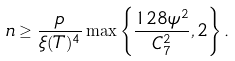<formula> <loc_0><loc_0><loc_500><loc_500>n \geq \frac { p } { \xi ( T ) ^ { 4 } } \max \left \{ \frac { 1 2 8 \psi ^ { 2 } } { C ^ { 2 } _ { 7 } } , 2 \right \} .</formula> 